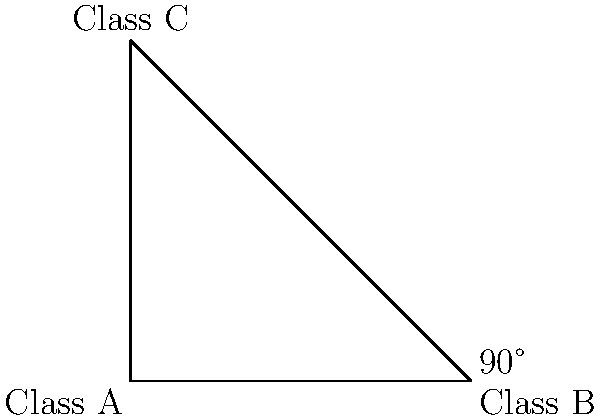In a UML class diagram, Class A and Class B are represented as perpendicular. If Class C forms a right-angled triangle with Classes A and B, what is the angle between Class A and Class C? To solve this problem, we need to apply our knowledge of right-angled triangles and the properties of perpendicular lines in Java class diagrams. Let's break it down step-by-step:

1. In a UML class diagram, perpendicular classes form a 90° angle.
2. The question states that Class A and Class B are perpendicular, so the angle between them is 90°.
3. Class C forms a right-angled triangle with Classes A and B, which means:
   a. The angle between Class B and Class C is also 90°.
   b. We now have a right-angled triangle where two angles are known: 90° (between B and C) and the angle we're looking for (between A and C).
4. In a triangle, the sum of all angles must equal 180°.
5. Let x be the angle between Class A and Class C. We can form an equation:
   $$ x + 90° + 90° = 180° $$
6. Simplifying the equation:
   $$ x + 180° = 180° $$
7. Solving for x:
   $$ x = 180° - 180° = 0° $$

Therefore, the angle between Class A and Class C in this UML class diagram is 0°.
Answer: 0° 